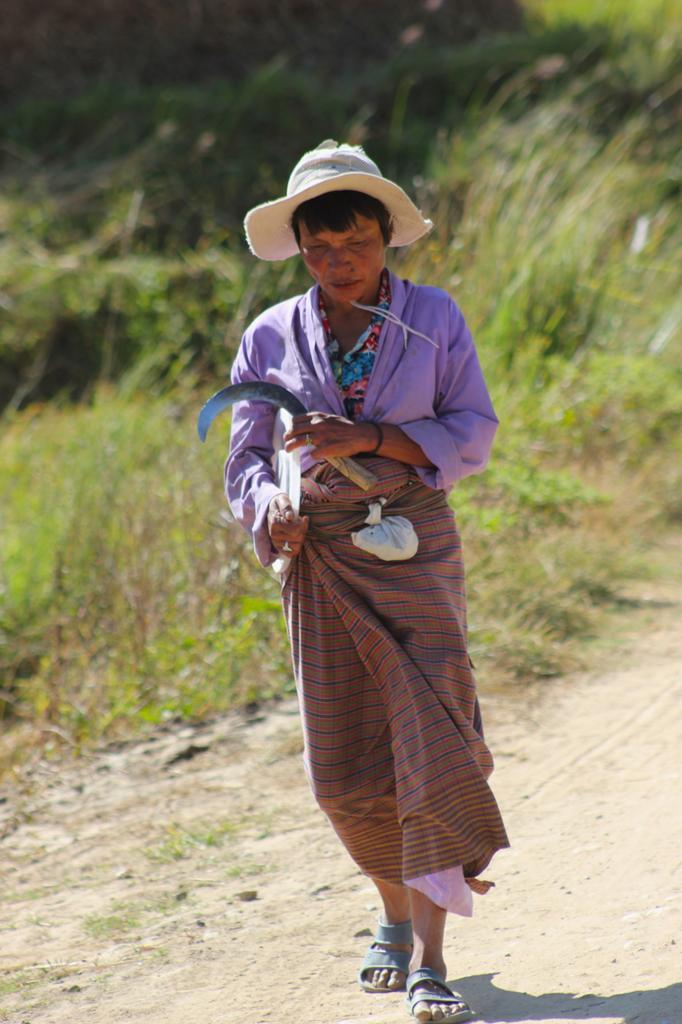Could you give a brief overview of what you see in this image? As we can see in the image there is a man standing and in the background there are plants and grass. 